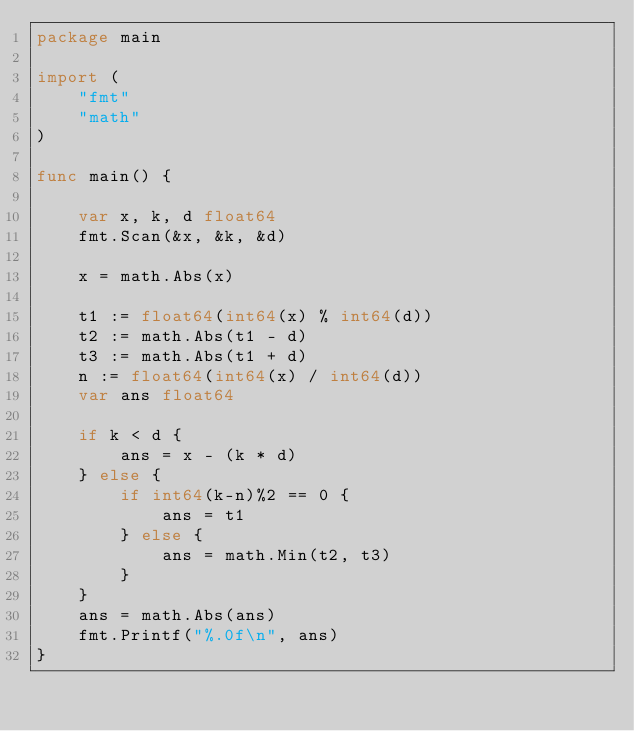<code> <loc_0><loc_0><loc_500><loc_500><_Go_>package main

import (
	"fmt"
	"math"
)

func main() {

	var x, k, d float64
	fmt.Scan(&x, &k, &d)
	
	x = math.Abs(x)

	t1 := float64(int64(x) % int64(d))
	t2 := math.Abs(t1 - d)
	t3 := math.Abs(t1 + d)
	n := float64(int64(x) / int64(d))
	var ans float64

	if k < d {
		ans = x - (k * d)
	} else {
		if int64(k-n)%2 == 0 {
			ans = t1
		} else {
			ans = math.Min(t2, t3)
		}
	}
	ans = math.Abs(ans)
	fmt.Printf("%.0f\n", ans)
}
</code> 